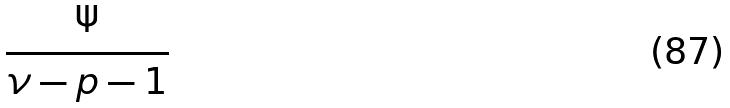<formula> <loc_0><loc_0><loc_500><loc_500>\frac { \Psi } { \nu - p - 1 }</formula> 